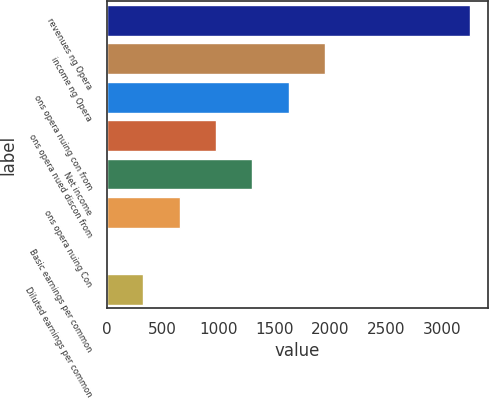Convert chart to OTSL. <chart><loc_0><loc_0><loc_500><loc_500><bar_chart><fcel>revenues ng Opera<fcel>income ng Opera<fcel>ons opera nuing con from<fcel>ons opera nued discon from<fcel>Net income<fcel>ons opera nuing Con<fcel>Basic earnings per common<fcel>Diluted earnings per common<nl><fcel>3248<fcel>1949.12<fcel>1624.39<fcel>974.93<fcel>1299.66<fcel>650.2<fcel>0.74<fcel>325.47<nl></chart> 